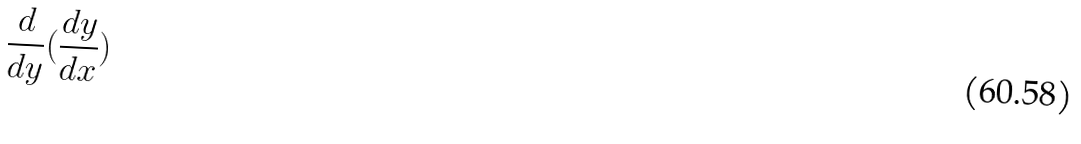<formula> <loc_0><loc_0><loc_500><loc_500>\frac { d } { d y } ( \frac { d y } { d x } )</formula> 